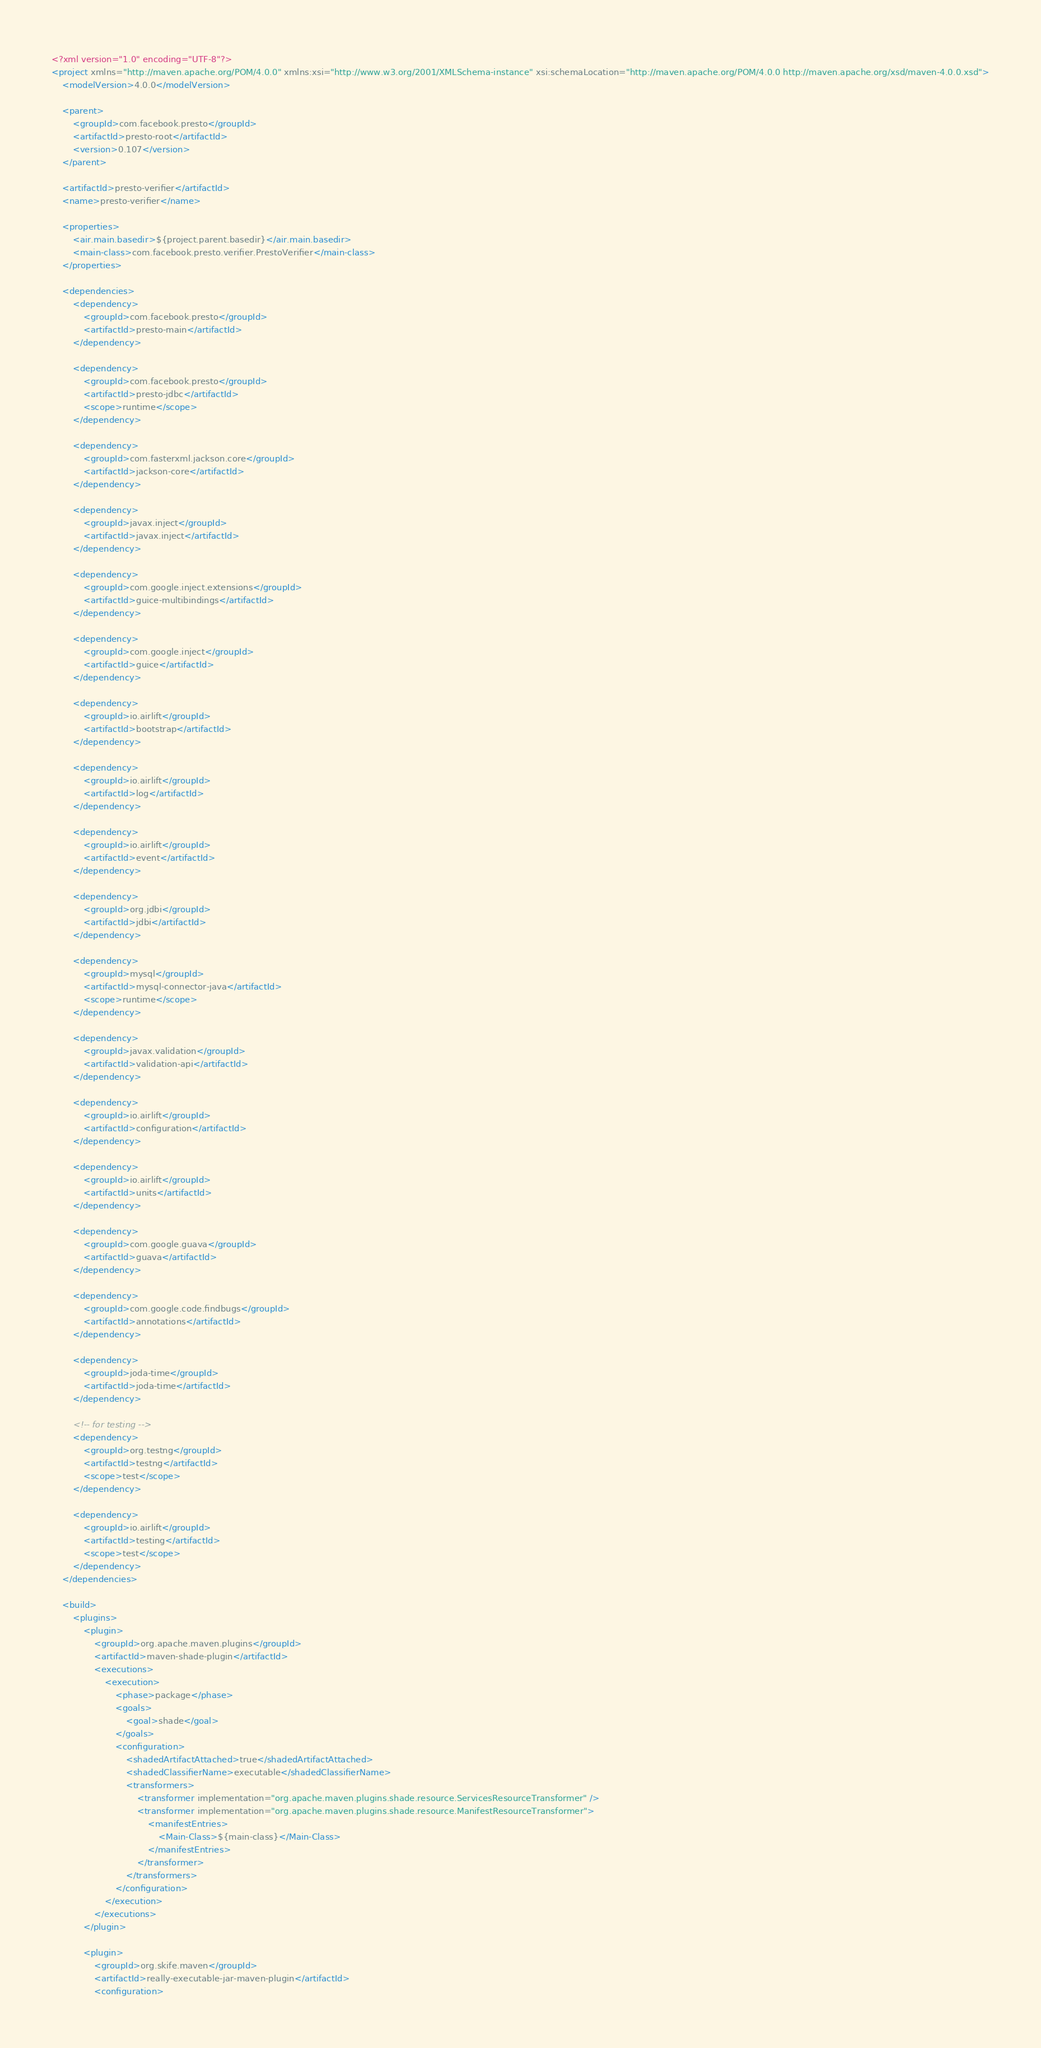Convert code to text. <code><loc_0><loc_0><loc_500><loc_500><_XML_><?xml version="1.0" encoding="UTF-8"?>
<project xmlns="http://maven.apache.org/POM/4.0.0" xmlns:xsi="http://www.w3.org/2001/XMLSchema-instance" xsi:schemaLocation="http://maven.apache.org/POM/4.0.0 http://maven.apache.org/xsd/maven-4.0.0.xsd">
    <modelVersion>4.0.0</modelVersion>

    <parent>
        <groupId>com.facebook.presto</groupId>
        <artifactId>presto-root</artifactId>
        <version>0.107</version>
    </parent>

    <artifactId>presto-verifier</artifactId>
    <name>presto-verifier</name>

    <properties>
        <air.main.basedir>${project.parent.basedir}</air.main.basedir>
        <main-class>com.facebook.presto.verifier.PrestoVerifier</main-class>
    </properties>

    <dependencies>
        <dependency>
            <groupId>com.facebook.presto</groupId>
            <artifactId>presto-main</artifactId>
        </dependency>

        <dependency>
            <groupId>com.facebook.presto</groupId>
            <artifactId>presto-jdbc</artifactId>
            <scope>runtime</scope>
        </dependency>

        <dependency>
            <groupId>com.fasterxml.jackson.core</groupId>
            <artifactId>jackson-core</artifactId>
        </dependency>

        <dependency>
            <groupId>javax.inject</groupId>
            <artifactId>javax.inject</artifactId>
        </dependency>

        <dependency>
            <groupId>com.google.inject.extensions</groupId>
            <artifactId>guice-multibindings</artifactId>
        </dependency>

        <dependency>
            <groupId>com.google.inject</groupId>
            <artifactId>guice</artifactId>
        </dependency>

        <dependency>
            <groupId>io.airlift</groupId>
            <artifactId>bootstrap</artifactId>
        </dependency>

        <dependency>
            <groupId>io.airlift</groupId>
            <artifactId>log</artifactId>
        </dependency>

        <dependency>
            <groupId>io.airlift</groupId>
            <artifactId>event</artifactId>
        </dependency>

        <dependency>
            <groupId>org.jdbi</groupId>
            <artifactId>jdbi</artifactId>
        </dependency>

        <dependency>
            <groupId>mysql</groupId>
            <artifactId>mysql-connector-java</artifactId>
            <scope>runtime</scope>
        </dependency>

        <dependency>
            <groupId>javax.validation</groupId>
            <artifactId>validation-api</artifactId>
        </dependency>

        <dependency>
            <groupId>io.airlift</groupId>
            <artifactId>configuration</artifactId>
        </dependency>

        <dependency>
            <groupId>io.airlift</groupId>
            <artifactId>units</artifactId>
        </dependency>

        <dependency>
            <groupId>com.google.guava</groupId>
            <artifactId>guava</artifactId>
        </dependency>

        <dependency>
            <groupId>com.google.code.findbugs</groupId>
            <artifactId>annotations</artifactId>
        </dependency>

        <dependency>
            <groupId>joda-time</groupId>
            <artifactId>joda-time</artifactId>
        </dependency>

        <!-- for testing -->
        <dependency>
            <groupId>org.testng</groupId>
            <artifactId>testng</artifactId>
            <scope>test</scope>
        </dependency>

        <dependency>
            <groupId>io.airlift</groupId>
            <artifactId>testing</artifactId>
            <scope>test</scope>
        </dependency>
    </dependencies>

    <build>
        <plugins>
            <plugin>
                <groupId>org.apache.maven.plugins</groupId>
                <artifactId>maven-shade-plugin</artifactId>
                <executions>
                    <execution>
                        <phase>package</phase>
                        <goals>
                            <goal>shade</goal>
                        </goals>
                        <configuration>
                            <shadedArtifactAttached>true</shadedArtifactAttached>
                            <shadedClassifierName>executable</shadedClassifierName>
                            <transformers>
                                <transformer implementation="org.apache.maven.plugins.shade.resource.ServicesResourceTransformer" />
                                <transformer implementation="org.apache.maven.plugins.shade.resource.ManifestResourceTransformer">
                                    <manifestEntries>
                                        <Main-Class>${main-class}</Main-Class>
                                    </manifestEntries>
                                </transformer>
                            </transformers>
                        </configuration>
                    </execution>
                </executions>
            </plugin>

            <plugin>
                <groupId>org.skife.maven</groupId>
                <artifactId>really-executable-jar-maven-plugin</artifactId>
                <configuration></code> 